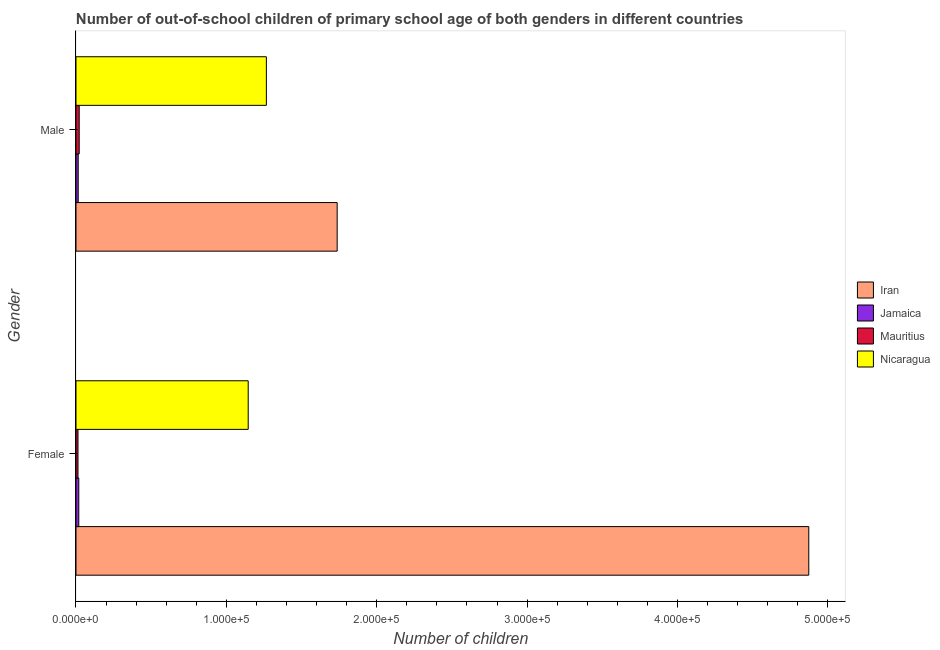How many different coloured bars are there?
Your answer should be compact. 4. How many groups of bars are there?
Give a very brief answer. 2. Are the number of bars per tick equal to the number of legend labels?
Your response must be concise. Yes. Are the number of bars on each tick of the Y-axis equal?
Your answer should be very brief. Yes. What is the number of female out-of-school students in Mauritius?
Offer a very short reply. 1331. Across all countries, what is the maximum number of male out-of-school students?
Ensure brevity in your answer.  1.74e+05. Across all countries, what is the minimum number of female out-of-school students?
Your response must be concise. 1331. In which country was the number of male out-of-school students maximum?
Your answer should be very brief. Iran. In which country was the number of male out-of-school students minimum?
Ensure brevity in your answer.  Jamaica. What is the total number of male out-of-school students in the graph?
Your answer should be compact. 3.04e+05. What is the difference between the number of female out-of-school students in Nicaragua and that in Jamaica?
Ensure brevity in your answer.  1.13e+05. What is the difference between the number of male out-of-school students in Iran and the number of female out-of-school students in Jamaica?
Provide a short and direct response. 1.72e+05. What is the average number of female out-of-school students per country?
Provide a short and direct response. 1.51e+05. What is the difference between the number of male out-of-school students and number of female out-of-school students in Iran?
Offer a terse response. -3.14e+05. In how many countries, is the number of male out-of-school students greater than 160000 ?
Provide a short and direct response. 1. What is the ratio of the number of female out-of-school students in Nicaragua to that in Jamaica?
Give a very brief answer. 61.54. Is the number of male out-of-school students in Jamaica less than that in Mauritius?
Provide a short and direct response. Yes. What does the 1st bar from the top in Female represents?
Offer a very short reply. Nicaragua. What does the 1st bar from the bottom in Male represents?
Ensure brevity in your answer.  Iran. Are all the bars in the graph horizontal?
Offer a very short reply. Yes. Are the values on the major ticks of X-axis written in scientific E-notation?
Make the answer very short. Yes. Does the graph contain any zero values?
Ensure brevity in your answer.  No. Does the graph contain grids?
Make the answer very short. No. How many legend labels are there?
Offer a very short reply. 4. How are the legend labels stacked?
Offer a terse response. Vertical. What is the title of the graph?
Provide a short and direct response. Number of out-of-school children of primary school age of both genders in different countries. What is the label or title of the X-axis?
Your response must be concise. Number of children. What is the label or title of the Y-axis?
Ensure brevity in your answer.  Gender. What is the Number of children in Iran in Female?
Your response must be concise. 4.87e+05. What is the Number of children in Jamaica in Female?
Provide a short and direct response. 1861. What is the Number of children of Mauritius in Female?
Keep it short and to the point. 1331. What is the Number of children in Nicaragua in Female?
Make the answer very short. 1.15e+05. What is the Number of children of Iran in Male?
Provide a succinct answer. 1.74e+05. What is the Number of children in Jamaica in Male?
Give a very brief answer. 1469. What is the Number of children of Mauritius in Male?
Your answer should be very brief. 2140. What is the Number of children in Nicaragua in Male?
Your answer should be compact. 1.27e+05. Across all Gender, what is the maximum Number of children in Iran?
Offer a terse response. 4.87e+05. Across all Gender, what is the maximum Number of children of Jamaica?
Your answer should be very brief. 1861. Across all Gender, what is the maximum Number of children of Mauritius?
Offer a terse response. 2140. Across all Gender, what is the maximum Number of children in Nicaragua?
Keep it short and to the point. 1.27e+05. Across all Gender, what is the minimum Number of children of Iran?
Your answer should be very brief. 1.74e+05. Across all Gender, what is the minimum Number of children of Jamaica?
Offer a very short reply. 1469. Across all Gender, what is the minimum Number of children in Mauritius?
Provide a short and direct response. 1331. Across all Gender, what is the minimum Number of children in Nicaragua?
Your answer should be compact. 1.15e+05. What is the total Number of children in Iran in the graph?
Offer a very short reply. 6.61e+05. What is the total Number of children in Jamaica in the graph?
Provide a succinct answer. 3330. What is the total Number of children in Mauritius in the graph?
Offer a terse response. 3471. What is the total Number of children of Nicaragua in the graph?
Provide a succinct answer. 2.41e+05. What is the difference between the Number of children in Iran in Female and that in Male?
Make the answer very short. 3.14e+05. What is the difference between the Number of children of Jamaica in Female and that in Male?
Make the answer very short. 392. What is the difference between the Number of children in Mauritius in Female and that in Male?
Your answer should be very brief. -809. What is the difference between the Number of children of Nicaragua in Female and that in Male?
Keep it short and to the point. -1.21e+04. What is the difference between the Number of children of Iran in Female and the Number of children of Jamaica in Male?
Give a very brief answer. 4.86e+05. What is the difference between the Number of children of Iran in Female and the Number of children of Mauritius in Male?
Keep it short and to the point. 4.85e+05. What is the difference between the Number of children of Iran in Female and the Number of children of Nicaragua in Male?
Your answer should be very brief. 3.61e+05. What is the difference between the Number of children of Jamaica in Female and the Number of children of Mauritius in Male?
Offer a very short reply. -279. What is the difference between the Number of children of Jamaica in Female and the Number of children of Nicaragua in Male?
Ensure brevity in your answer.  -1.25e+05. What is the difference between the Number of children of Mauritius in Female and the Number of children of Nicaragua in Male?
Your answer should be very brief. -1.25e+05. What is the average Number of children in Iran per Gender?
Your response must be concise. 3.30e+05. What is the average Number of children in Jamaica per Gender?
Ensure brevity in your answer.  1665. What is the average Number of children of Mauritius per Gender?
Give a very brief answer. 1735.5. What is the average Number of children of Nicaragua per Gender?
Your answer should be very brief. 1.21e+05. What is the difference between the Number of children in Iran and Number of children in Jamaica in Female?
Provide a succinct answer. 4.85e+05. What is the difference between the Number of children in Iran and Number of children in Mauritius in Female?
Offer a terse response. 4.86e+05. What is the difference between the Number of children of Iran and Number of children of Nicaragua in Female?
Keep it short and to the point. 3.73e+05. What is the difference between the Number of children in Jamaica and Number of children in Mauritius in Female?
Offer a very short reply. 530. What is the difference between the Number of children in Jamaica and Number of children in Nicaragua in Female?
Make the answer very short. -1.13e+05. What is the difference between the Number of children of Mauritius and Number of children of Nicaragua in Female?
Keep it short and to the point. -1.13e+05. What is the difference between the Number of children in Iran and Number of children in Jamaica in Male?
Keep it short and to the point. 1.72e+05. What is the difference between the Number of children in Iran and Number of children in Mauritius in Male?
Your answer should be very brief. 1.72e+05. What is the difference between the Number of children of Iran and Number of children of Nicaragua in Male?
Provide a succinct answer. 4.71e+04. What is the difference between the Number of children of Jamaica and Number of children of Mauritius in Male?
Provide a short and direct response. -671. What is the difference between the Number of children in Jamaica and Number of children in Nicaragua in Male?
Give a very brief answer. -1.25e+05. What is the difference between the Number of children in Mauritius and Number of children in Nicaragua in Male?
Your answer should be very brief. -1.24e+05. What is the ratio of the Number of children in Iran in Female to that in Male?
Ensure brevity in your answer.  2.81. What is the ratio of the Number of children of Jamaica in Female to that in Male?
Keep it short and to the point. 1.27. What is the ratio of the Number of children of Mauritius in Female to that in Male?
Your answer should be compact. 0.62. What is the ratio of the Number of children in Nicaragua in Female to that in Male?
Provide a succinct answer. 0.9. What is the difference between the highest and the second highest Number of children in Iran?
Offer a very short reply. 3.14e+05. What is the difference between the highest and the second highest Number of children of Jamaica?
Ensure brevity in your answer.  392. What is the difference between the highest and the second highest Number of children in Mauritius?
Give a very brief answer. 809. What is the difference between the highest and the second highest Number of children in Nicaragua?
Offer a very short reply. 1.21e+04. What is the difference between the highest and the lowest Number of children in Iran?
Offer a very short reply. 3.14e+05. What is the difference between the highest and the lowest Number of children in Jamaica?
Ensure brevity in your answer.  392. What is the difference between the highest and the lowest Number of children in Mauritius?
Offer a terse response. 809. What is the difference between the highest and the lowest Number of children in Nicaragua?
Provide a succinct answer. 1.21e+04. 